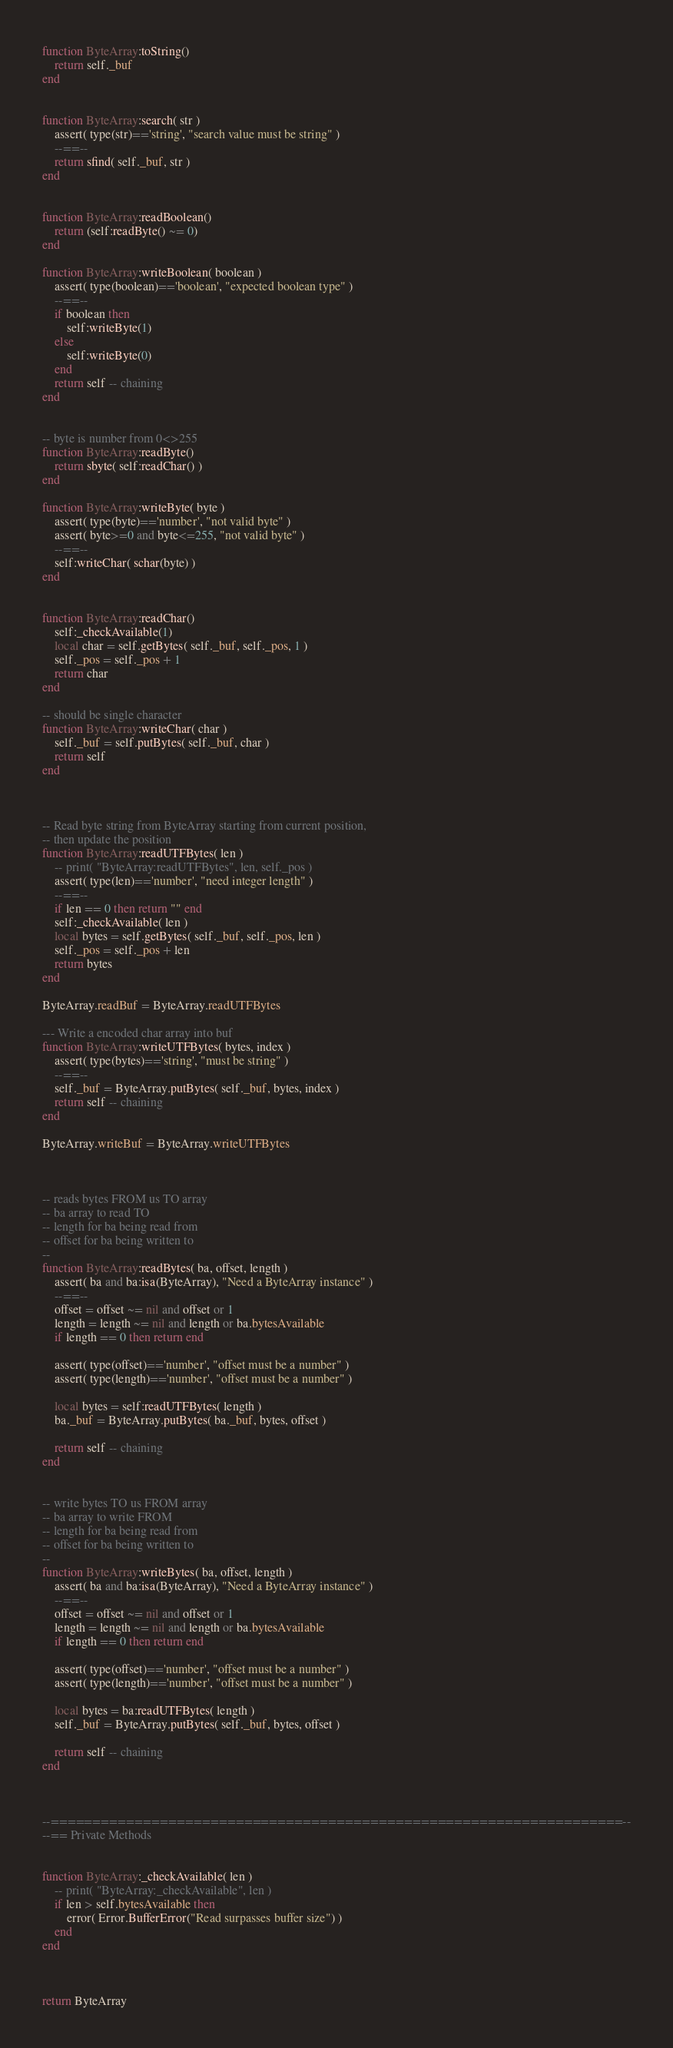<code> <loc_0><loc_0><loc_500><loc_500><_Lua_>
function ByteArray:toString()
	return self._buf
end


function ByteArray:search( str )
	assert( type(str)=='string', "search value must be string" )
	--==--
	return sfind( self._buf, str )
end


function ByteArray:readBoolean()
	return (self:readByte() ~= 0)
end

function ByteArray:writeBoolean( boolean )
	assert( type(boolean)=='boolean', "expected boolean type" )
	--==--
	if boolean then
		self:writeByte(1)
	else
		self:writeByte(0)
	end
	return self -- chaining
end


-- byte is number from 0<>255
function ByteArray:readByte()
	return sbyte( self:readChar() )
end

function ByteArray:writeByte( byte )
	assert( type(byte)=='number', "not valid byte" )
	assert( byte>=0 and byte<=255, "not valid byte" )
	--==--
	self:writeChar( schar(byte) )
end


function ByteArray:readChar()
	self:_checkAvailable(1)
	local char = self.getBytes( self._buf, self._pos, 1 )
	self._pos = self._pos + 1
	return char
end

-- should be single character
function ByteArray:writeChar( char )
	self._buf = self.putBytes( self._buf, char )
	return self
end



-- Read byte string from ByteArray starting from current position,
-- then update the position
function ByteArray:readUTFBytes( len )
	-- print( "ByteArray:readUTFBytes", len, self._pos )
	assert( type(len)=='number', "need integer length" )
	--==--
	if len == 0 then return "" end
	self:_checkAvailable( len )
	local bytes = self.getBytes( self._buf, self._pos, len )
	self._pos = self._pos + len
	return bytes
end

ByteArray.readBuf = ByteArray.readUTFBytes

--- Write a encoded char array into buf
function ByteArray:writeUTFBytes( bytes, index )
	assert( type(bytes)=='string', "must be string" )
	--==--
	self._buf = ByteArray.putBytes( self._buf, bytes, index )
	return self -- chaining
end

ByteArray.writeBuf = ByteArray.writeUTFBytes



-- reads bytes FROM us TO array
-- ba array to read TO
-- length for ba being read from
-- offset for ba being written to
--
function ByteArray:readBytes( ba, offset, length )
	assert( ba and ba:isa(ByteArray), "Need a ByteArray instance" )
	--==--
	offset = offset ~= nil and offset or 1
	length = length ~= nil and length or ba.bytesAvailable
	if length == 0 then return end

	assert( type(offset)=='number', "offset must be a number" )
	assert( type(length)=='number', "offset must be a number" )

	local bytes = self:readUTFBytes( length )
	ba._buf = ByteArray.putBytes( ba._buf, bytes, offset )

	return self -- chaining
end


-- write bytes TO us FROM array
-- ba array to write FROM
-- length for ba being read from
-- offset for ba being written to
--
function ByteArray:writeBytes( ba, offset, length )
	assert( ba and ba:isa(ByteArray), "Need a ByteArray instance" )
	--==--
	offset = offset ~= nil and offset or 1
	length = length ~= nil and length or ba.bytesAvailable
	if length == 0 then return end

	assert( type(offset)=='number', "offset must be a number" )
	assert( type(length)=='number', "offset must be a number" )

	local bytes = ba:readUTFBytes( length )
	self._buf = ByteArray.putBytes( self._buf, bytes, offset )

	return self -- chaining
end



--====================================================================--
--== Private Methods


function ByteArray:_checkAvailable( len )
	-- print( "ByteArray:_checkAvailable", len )
	if len > self.bytesAvailable then
		error( Error.BufferError("Read surpasses buffer size") )
	end
end



return ByteArray
</code> 